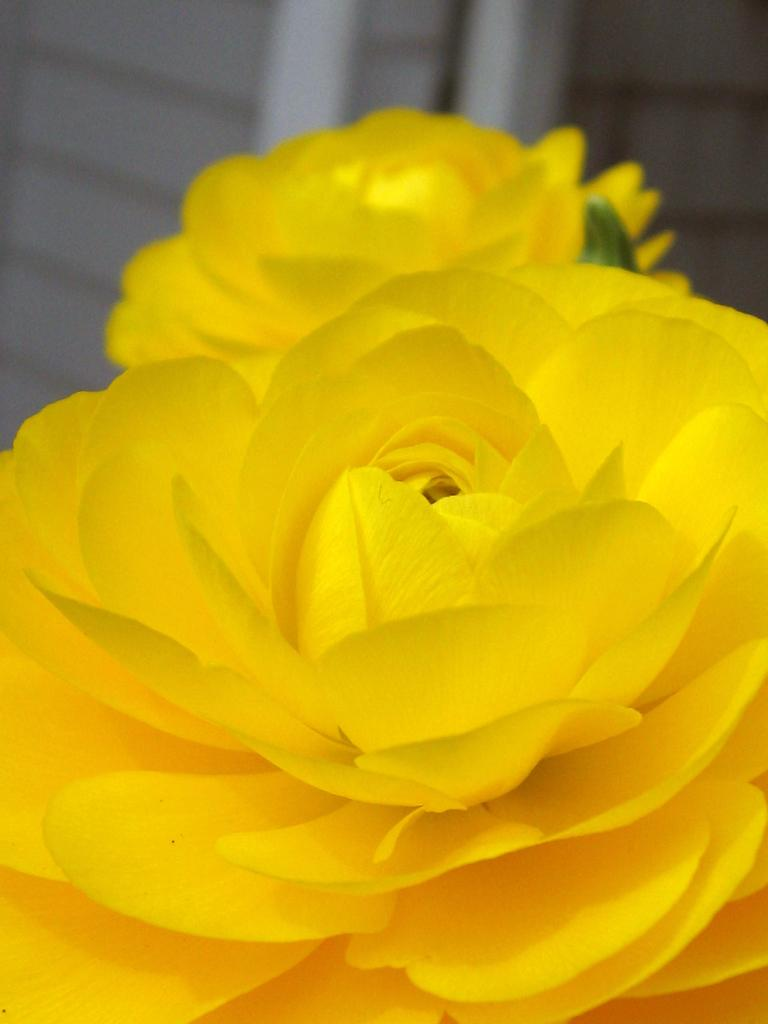What type of living organisms can be seen in the image? There are flowers in the image. Can you describe the background of the image? The background of the image is blurred. How does the skin of the flowers appear in the image? There is no mention of skin in the image, as it features flowers and a blurred background. 